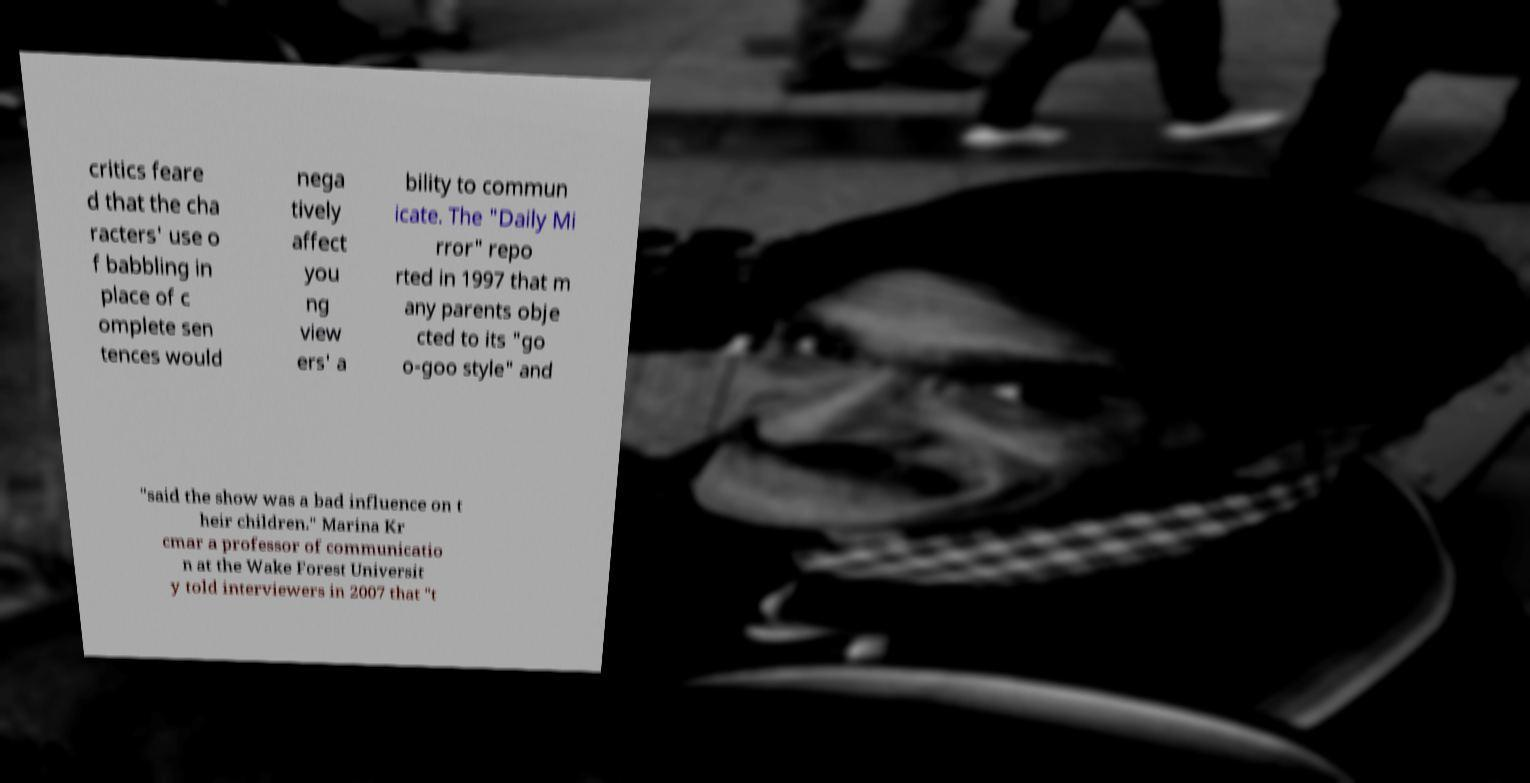Can you accurately transcribe the text from the provided image for me? critics feare d that the cha racters' use o f babbling in place of c omplete sen tences would nega tively affect you ng view ers' a bility to commun icate. The "Daily Mi rror" repo rted in 1997 that m any parents obje cted to its "go o-goo style" and "said the show was a bad influence on t heir children." Marina Kr cmar a professor of communicatio n at the Wake Forest Universit y told interviewers in 2007 that "t 